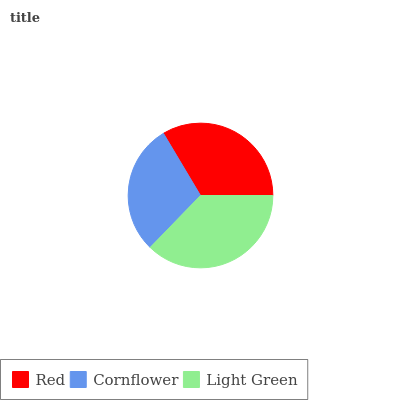Is Cornflower the minimum?
Answer yes or no. Yes. Is Light Green the maximum?
Answer yes or no. Yes. Is Light Green the minimum?
Answer yes or no. No. Is Cornflower the maximum?
Answer yes or no. No. Is Light Green greater than Cornflower?
Answer yes or no. Yes. Is Cornflower less than Light Green?
Answer yes or no. Yes. Is Cornflower greater than Light Green?
Answer yes or no. No. Is Light Green less than Cornflower?
Answer yes or no. No. Is Red the high median?
Answer yes or no. Yes. Is Red the low median?
Answer yes or no. Yes. Is Light Green the high median?
Answer yes or no. No. Is Light Green the low median?
Answer yes or no. No. 